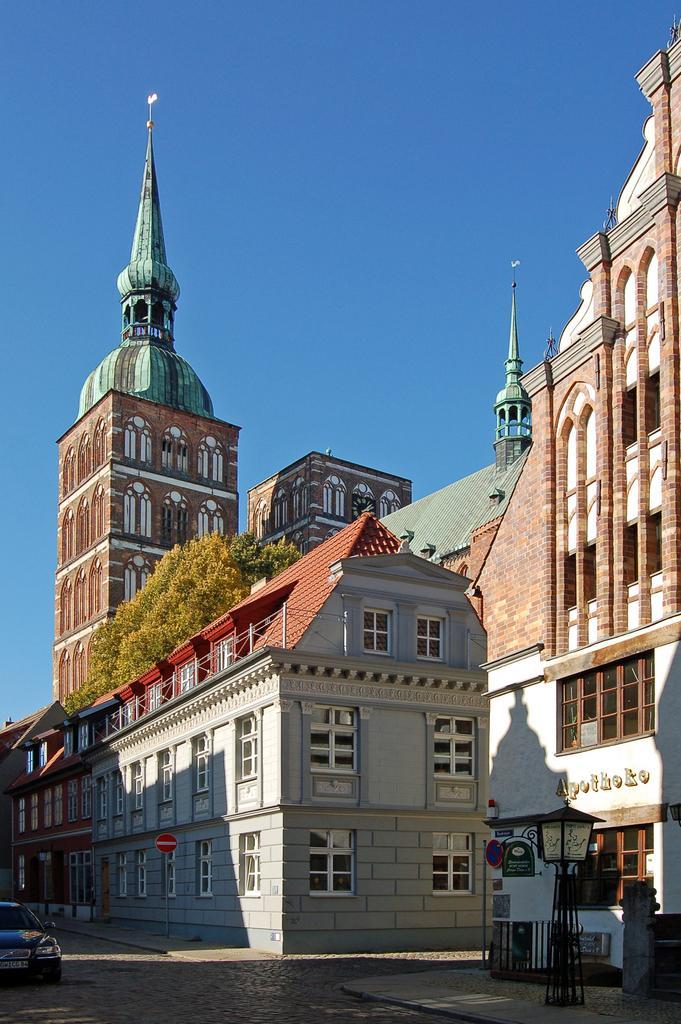How would you summarize this image in a sentence or two? In this image we can see buildings, trees, street poles, street lights, name board, motor vehicle on the road and sky. 